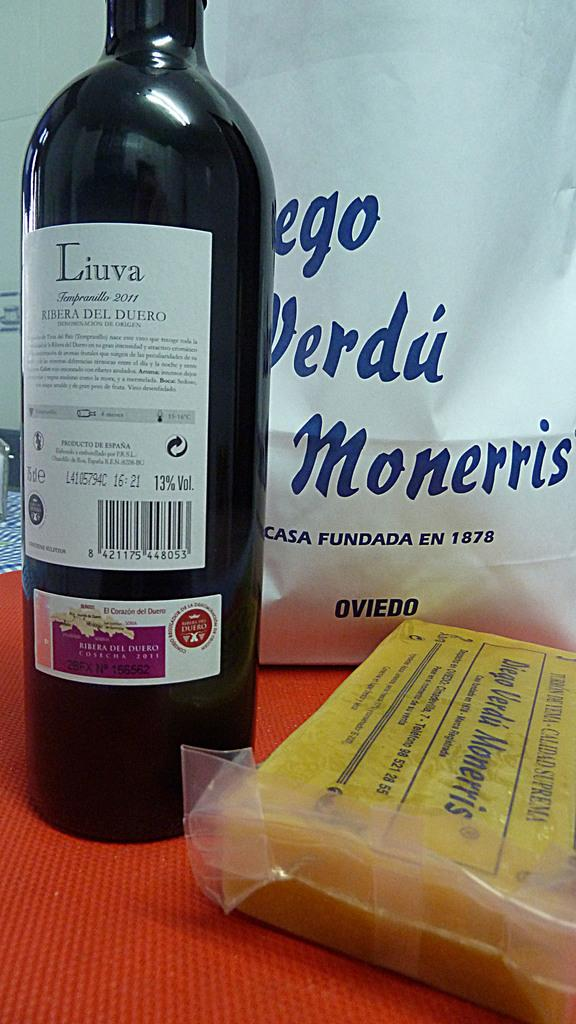Provide a one-sentence caption for the provided image. A tall bottle with the label Liuva written on it. 